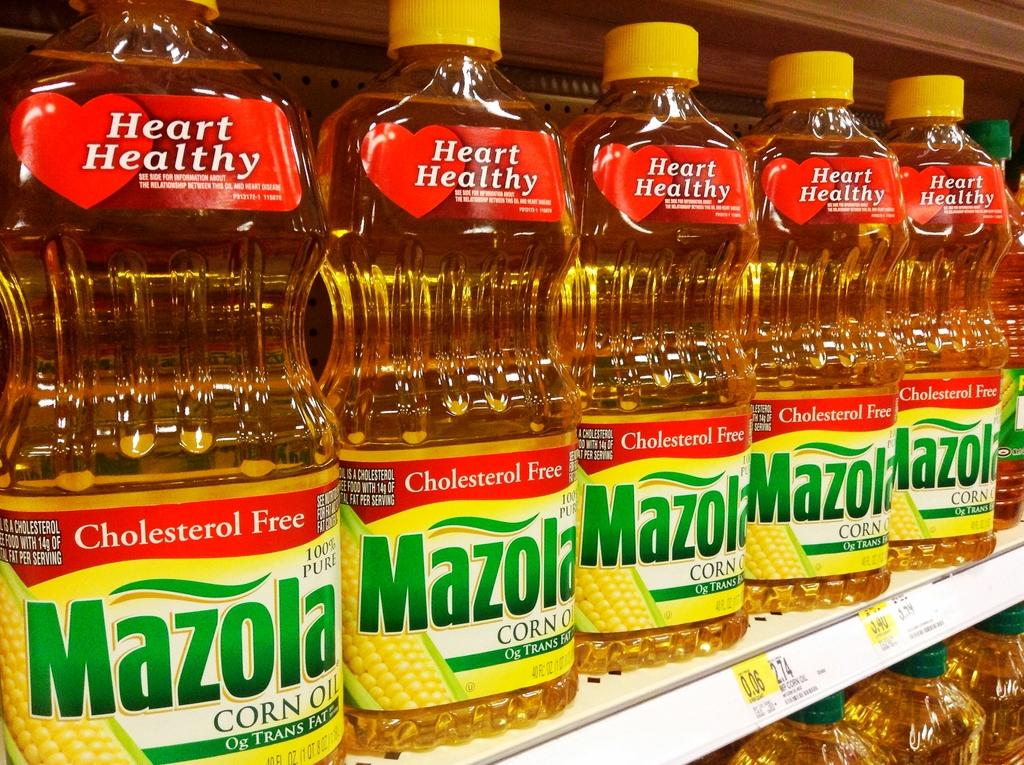<image>
Summarize the visual content of the image. mazola oil sits on the shelfs of the grocery store 